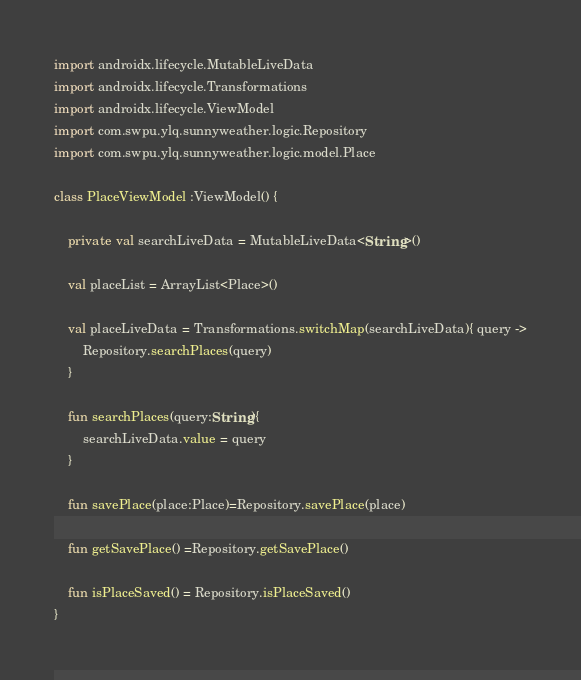<code> <loc_0><loc_0><loc_500><loc_500><_Kotlin_>
import androidx.lifecycle.MutableLiveData
import androidx.lifecycle.Transformations
import androidx.lifecycle.ViewModel
import com.swpu.ylq.sunnyweather.logic.Repository
import com.swpu.ylq.sunnyweather.logic.model.Place

class PlaceViewModel :ViewModel() {

    private val searchLiveData = MutableLiveData<String>()

    val placeList = ArrayList<Place>()

    val placeLiveData = Transformations.switchMap(searchLiveData){ query ->
        Repository.searchPlaces(query)
    }

    fun searchPlaces(query:String){
        searchLiveData.value = query
    }

    fun savePlace(place:Place)=Repository.savePlace(place)

    fun getSavePlace() =Repository.getSavePlace()

    fun isPlaceSaved() = Repository.isPlaceSaved()
}</code> 